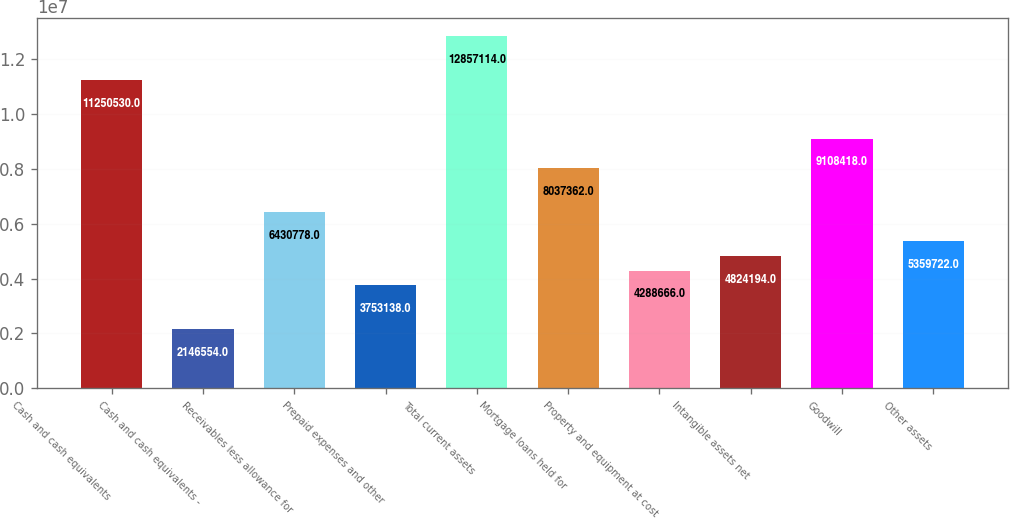Convert chart to OTSL. <chart><loc_0><loc_0><loc_500><loc_500><bar_chart><fcel>Cash and cash equivalents<fcel>Cash and cash equivalents -<fcel>Receivables less allowance for<fcel>Prepaid expenses and other<fcel>Total current assets<fcel>Mortgage loans held for<fcel>Property and equipment at cost<fcel>Intangible assets net<fcel>Goodwill<fcel>Other assets<nl><fcel>1.12505e+07<fcel>2.14655e+06<fcel>6.43078e+06<fcel>3.75314e+06<fcel>1.28571e+07<fcel>8.03736e+06<fcel>4.28867e+06<fcel>4.82419e+06<fcel>9.10842e+06<fcel>5.35972e+06<nl></chart> 